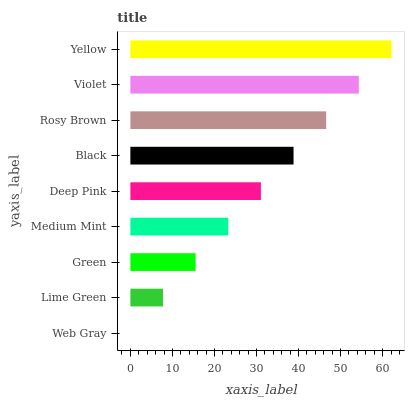Is Web Gray the minimum?
Answer yes or no. Yes. Is Yellow the maximum?
Answer yes or no. Yes. Is Lime Green the minimum?
Answer yes or no. No. Is Lime Green the maximum?
Answer yes or no. No. Is Lime Green greater than Web Gray?
Answer yes or no. Yes. Is Web Gray less than Lime Green?
Answer yes or no. Yes. Is Web Gray greater than Lime Green?
Answer yes or no. No. Is Lime Green less than Web Gray?
Answer yes or no. No. Is Deep Pink the high median?
Answer yes or no. Yes. Is Deep Pink the low median?
Answer yes or no. Yes. Is Yellow the high median?
Answer yes or no. No. Is Yellow the low median?
Answer yes or no. No. 